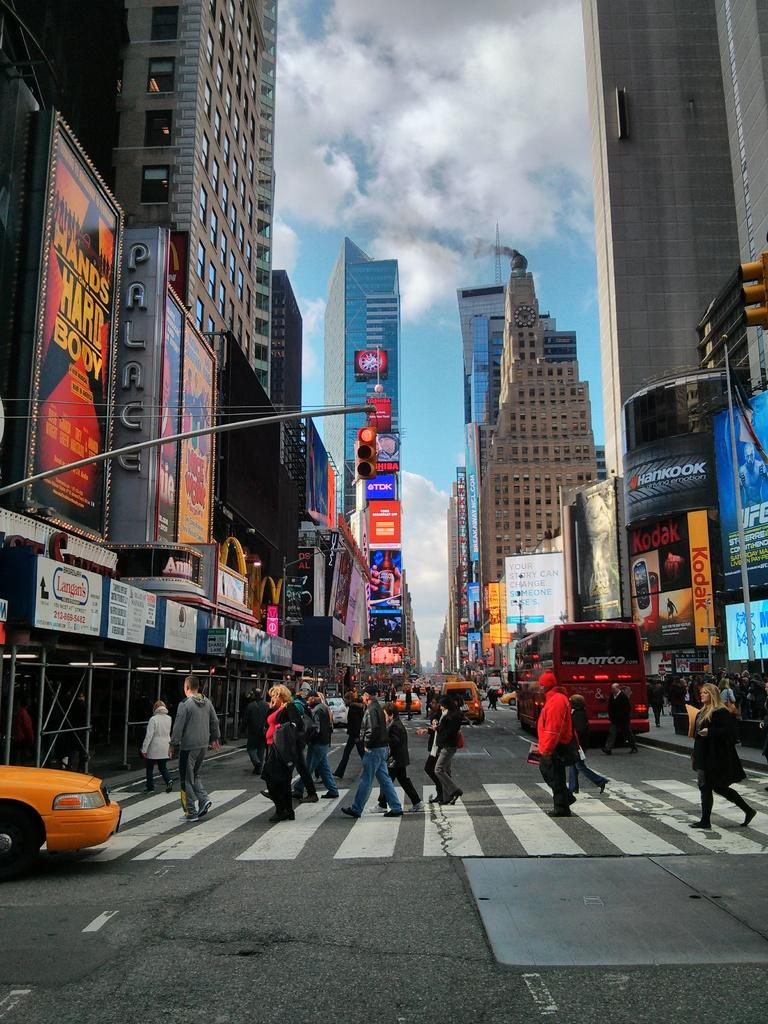<image>
Write a terse but informative summary of the picture. A busy street scene with an advert for Annie on the left. 